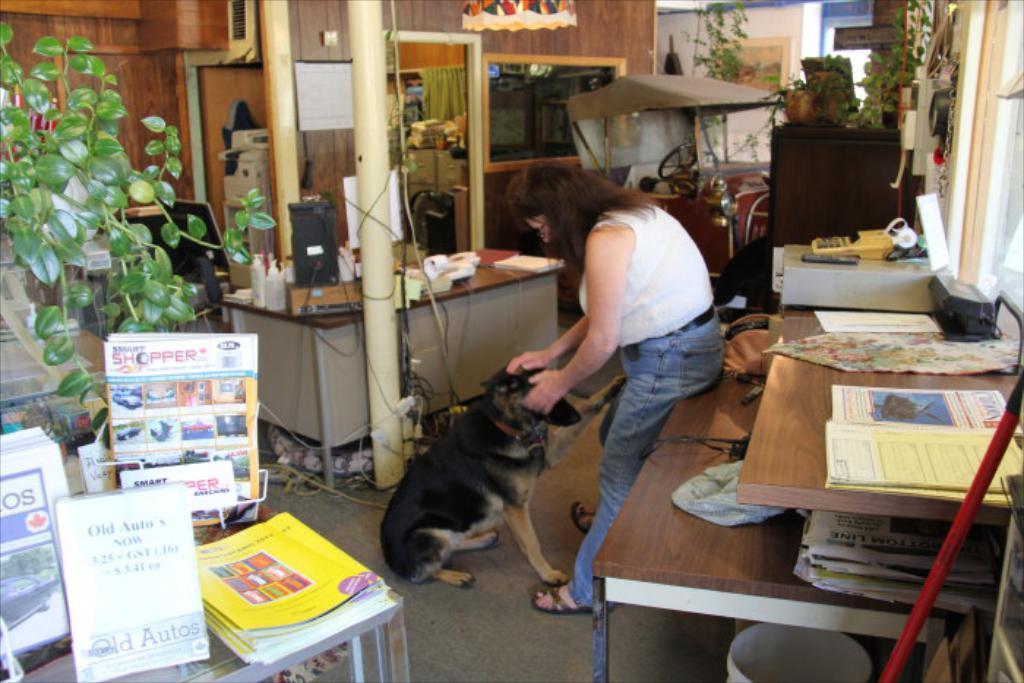How would you summarize this image in a sentence or two? Here we can see a woman who is standing on the floor. This is dog. These are the tables. On the table there are papers, books, and bottles. This is pole and there is a plant. Here we can see a vehicle and this is door. 